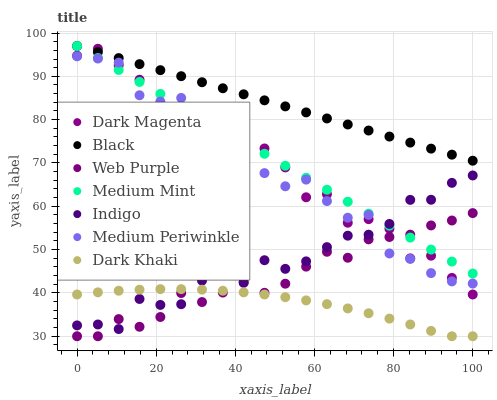Does Dark Khaki have the minimum area under the curve?
Answer yes or no. Yes. Does Black have the maximum area under the curve?
Answer yes or no. Yes. Does Indigo have the minimum area under the curve?
Answer yes or no. No. Does Indigo have the maximum area under the curve?
Answer yes or no. No. Is Medium Mint the smoothest?
Answer yes or no. Yes. Is Dark Magenta the roughest?
Answer yes or no. Yes. Is Indigo the smoothest?
Answer yes or no. No. Is Indigo the roughest?
Answer yes or no. No. Does Dark Khaki have the lowest value?
Answer yes or no. Yes. Does Indigo have the lowest value?
Answer yes or no. No. Does Black have the highest value?
Answer yes or no. Yes. Does Indigo have the highest value?
Answer yes or no. No. Is Dark Khaki less than Black?
Answer yes or no. Yes. Is Black greater than Dark Khaki?
Answer yes or no. Yes. Does Dark Magenta intersect Medium Periwinkle?
Answer yes or no. Yes. Is Dark Magenta less than Medium Periwinkle?
Answer yes or no. No. Is Dark Magenta greater than Medium Periwinkle?
Answer yes or no. No. Does Dark Khaki intersect Black?
Answer yes or no. No. 